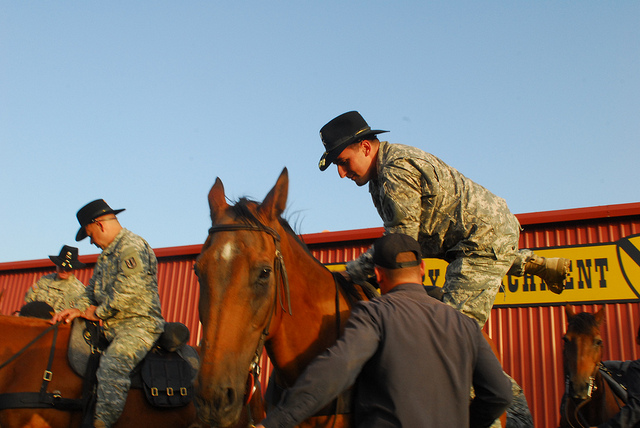Identify the text displayed in this image. V CAMENT 